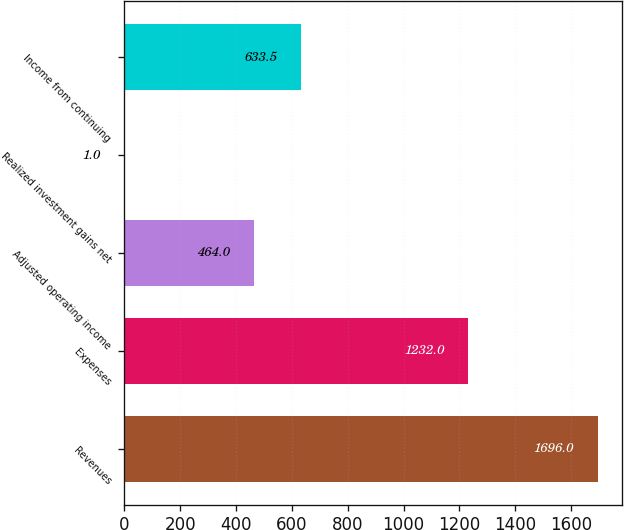Convert chart. <chart><loc_0><loc_0><loc_500><loc_500><bar_chart><fcel>Revenues<fcel>Expenses<fcel>Adjusted operating income<fcel>Realized investment gains net<fcel>Income from continuing<nl><fcel>1696<fcel>1232<fcel>464<fcel>1<fcel>633.5<nl></chart> 